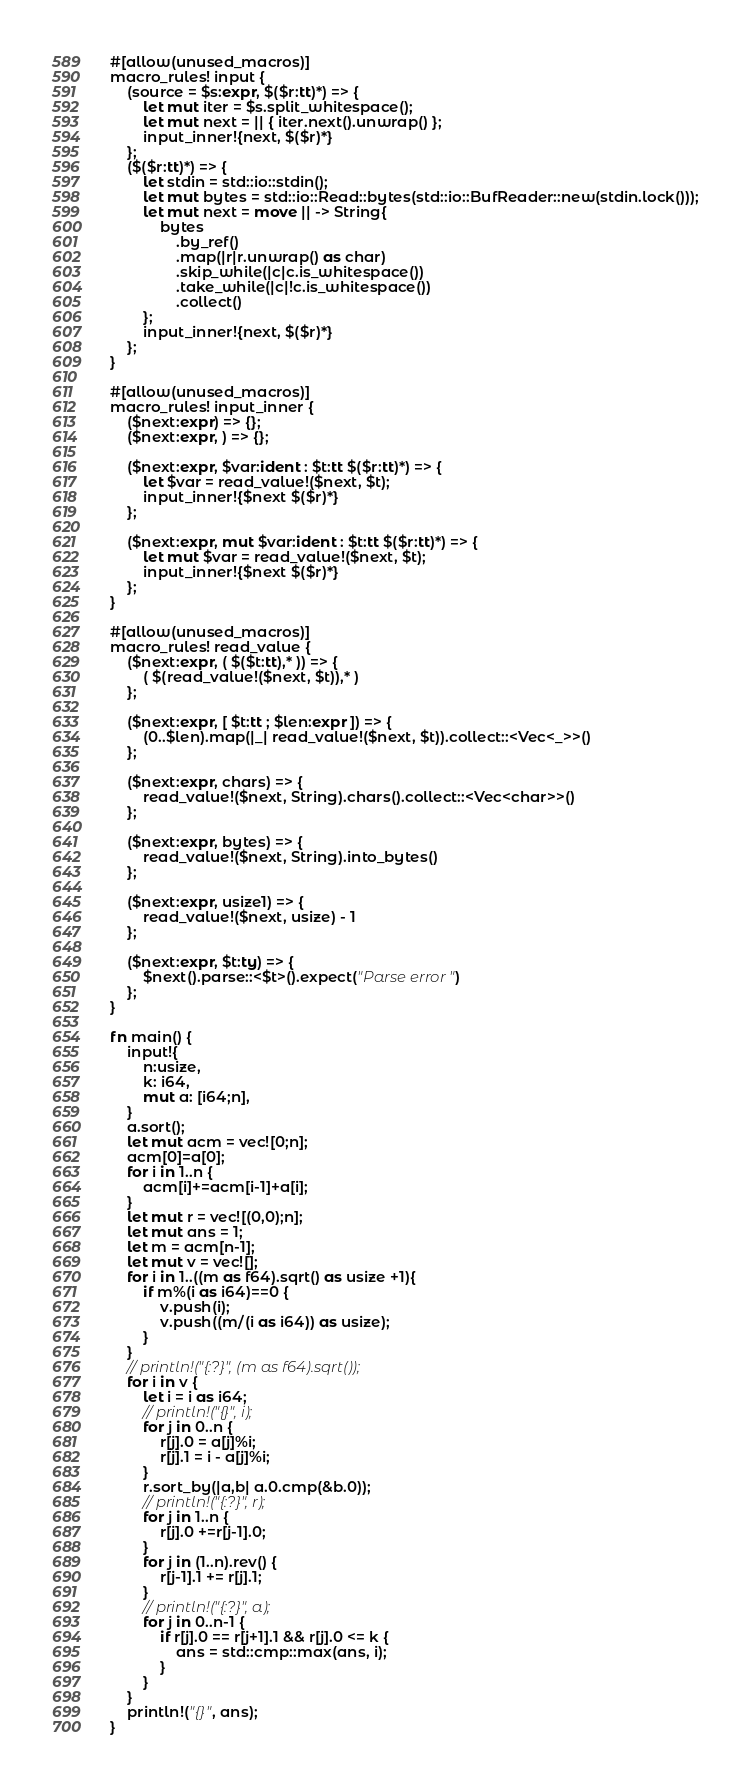Convert code to text. <code><loc_0><loc_0><loc_500><loc_500><_Rust_>#[allow(unused_macros)]
macro_rules! input {
    (source = $s:expr, $($r:tt)*) => {
        let mut iter = $s.split_whitespace();
        let mut next = || { iter.next().unwrap() };
        input_inner!{next, $($r)*}
    };
    ($($r:tt)*) => {
        let stdin = std::io::stdin();
        let mut bytes = std::io::Read::bytes(std::io::BufReader::new(stdin.lock()));
        let mut next = move || -> String{
            bytes
                .by_ref()
                .map(|r|r.unwrap() as char)
                .skip_while(|c|c.is_whitespace())
                .take_while(|c|!c.is_whitespace())
                .collect()
        };
        input_inner!{next, $($r)*}
    };
}

#[allow(unused_macros)]
macro_rules! input_inner {
    ($next:expr) => {};
    ($next:expr, ) => {};

    ($next:expr, $var:ident : $t:tt $($r:tt)*) => {
        let $var = read_value!($next, $t);
        input_inner!{$next $($r)*}
    };

    ($next:expr, mut $var:ident : $t:tt $($r:tt)*) => {
        let mut $var = read_value!($next, $t);
        input_inner!{$next $($r)*}
    };
}

#[allow(unused_macros)]
macro_rules! read_value {
    ($next:expr, ( $($t:tt),* )) => {
        ( $(read_value!($next, $t)),* )
    };

    ($next:expr, [ $t:tt ; $len:expr ]) => {
        (0..$len).map(|_| read_value!($next, $t)).collect::<Vec<_>>()
    };

    ($next:expr, chars) => {
        read_value!($next, String).chars().collect::<Vec<char>>()
    };

    ($next:expr, bytes) => {
        read_value!($next, String).into_bytes()
    };

    ($next:expr, usize1) => {
        read_value!($next, usize) - 1
    };

    ($next:expr, $t:ty) => {
        $next().parse::<$t>().expect("Parse error")
    };
}

fn main() {
    input!{
        n:usize,
        k: i64,
        mut a: [i64;n],
    }
    a.sort();
    let mut acm = vec![0;n];
    acm[0]=a[0];
    for i in 1..n {
        acm[i]+=acm[i-1]+a[i];
    }
    let mut r = vec![(0,0);n];
    let mut ans = 1;
    let m = acm[n-1];
    let mut v = vec![];
    for i in 1..((m as f64).sqrt() as usize +1){
        if m%(i as i64)==0 {
            v.push(i);
            v.push((m/(i as i64)) as usize);
        }
    }
    // println!("{:?}", (m as f64).sqrt());
    for i in v {
        let i = i as i64;
        // println!("{}", i);
        for j in 0..n {
            r[j].0 = a[j]%i;
            r[j].1 = i - a[j]%i;
        }
        r.sort_by(|a,b| a.0.cmp(&b.0));
        // println!("{:?}", r);
        for j in 1..n {
            r[j].0 +=r[j-1].0;
        }
        for j in (1..n).rev() {
            r[j-1].1 += r[j].1;
        }
        // println!("{:?}", a);
        for j in 0..n-1 {
            if r[j].0 == r[j+1].1 && r[j].0 <= k {
                ans = std::cmp::max(ans, i);
            }
        }
    }
    println!("{}", ans);
}</code> 